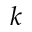<formula> <loc_0><loc_0><loc_500><loc_500>k</formula> 